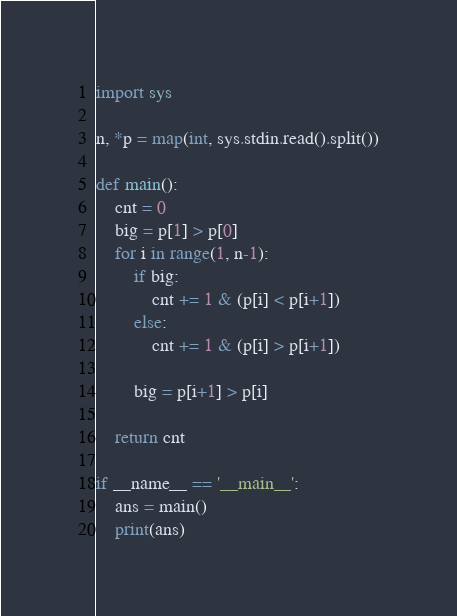Convert code to text. <code><loc_0><loc_0><loc_500><loc_500><_Python_>import sys

n, *p = map(int, sys.stdin.read().split())

def main():
    cnt = 0
    big = p[1] > p[0]
    for i in range(1, n-1):
        if big:
            cnt += 1 & (p[i] < p[i+1])
        else:
            cnt += 1 & (p[i] > p[i+1])
            
        big = p[i+1] > p[i]

    return cnt

if __name__ == '__main__':
    ans = main()
    print(ans)</code> 